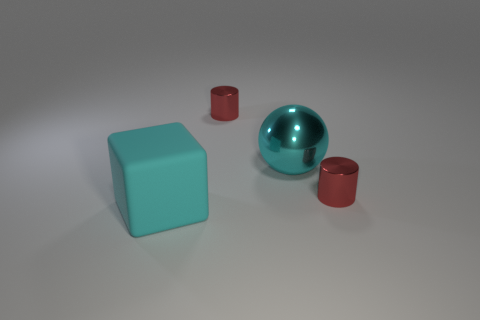Is there a red object behind the tiny red metallic cylinder that is to the left of the large sphere? After carefully examining the image, no additional red objects are located behind the small red metallic cylinder positioned to the left of the prominent sphere. The background and surrounding area are clear of any other red objects. 